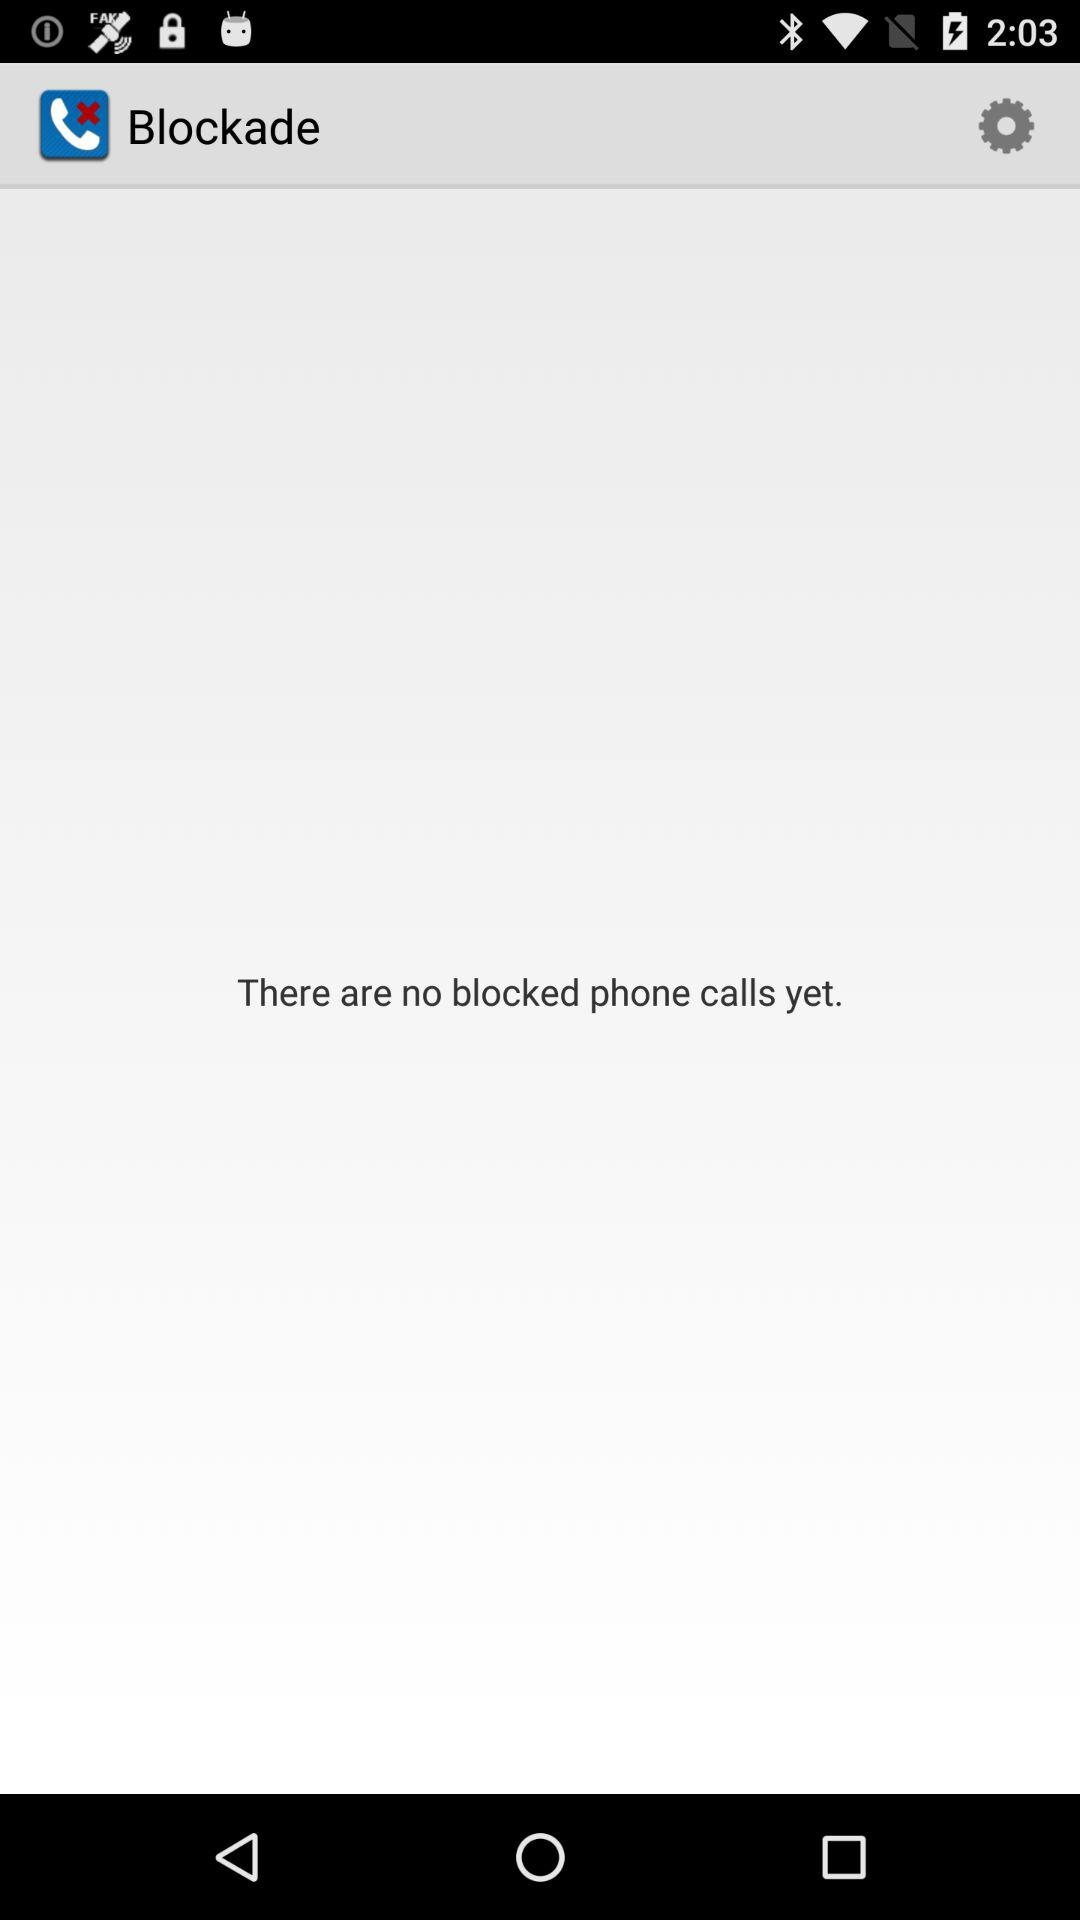How many blocked phone calls are there?
Answer the question using a single word or phrase. 0 